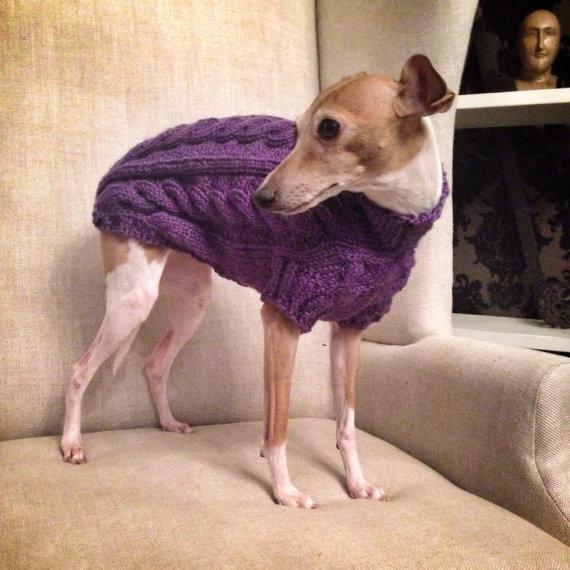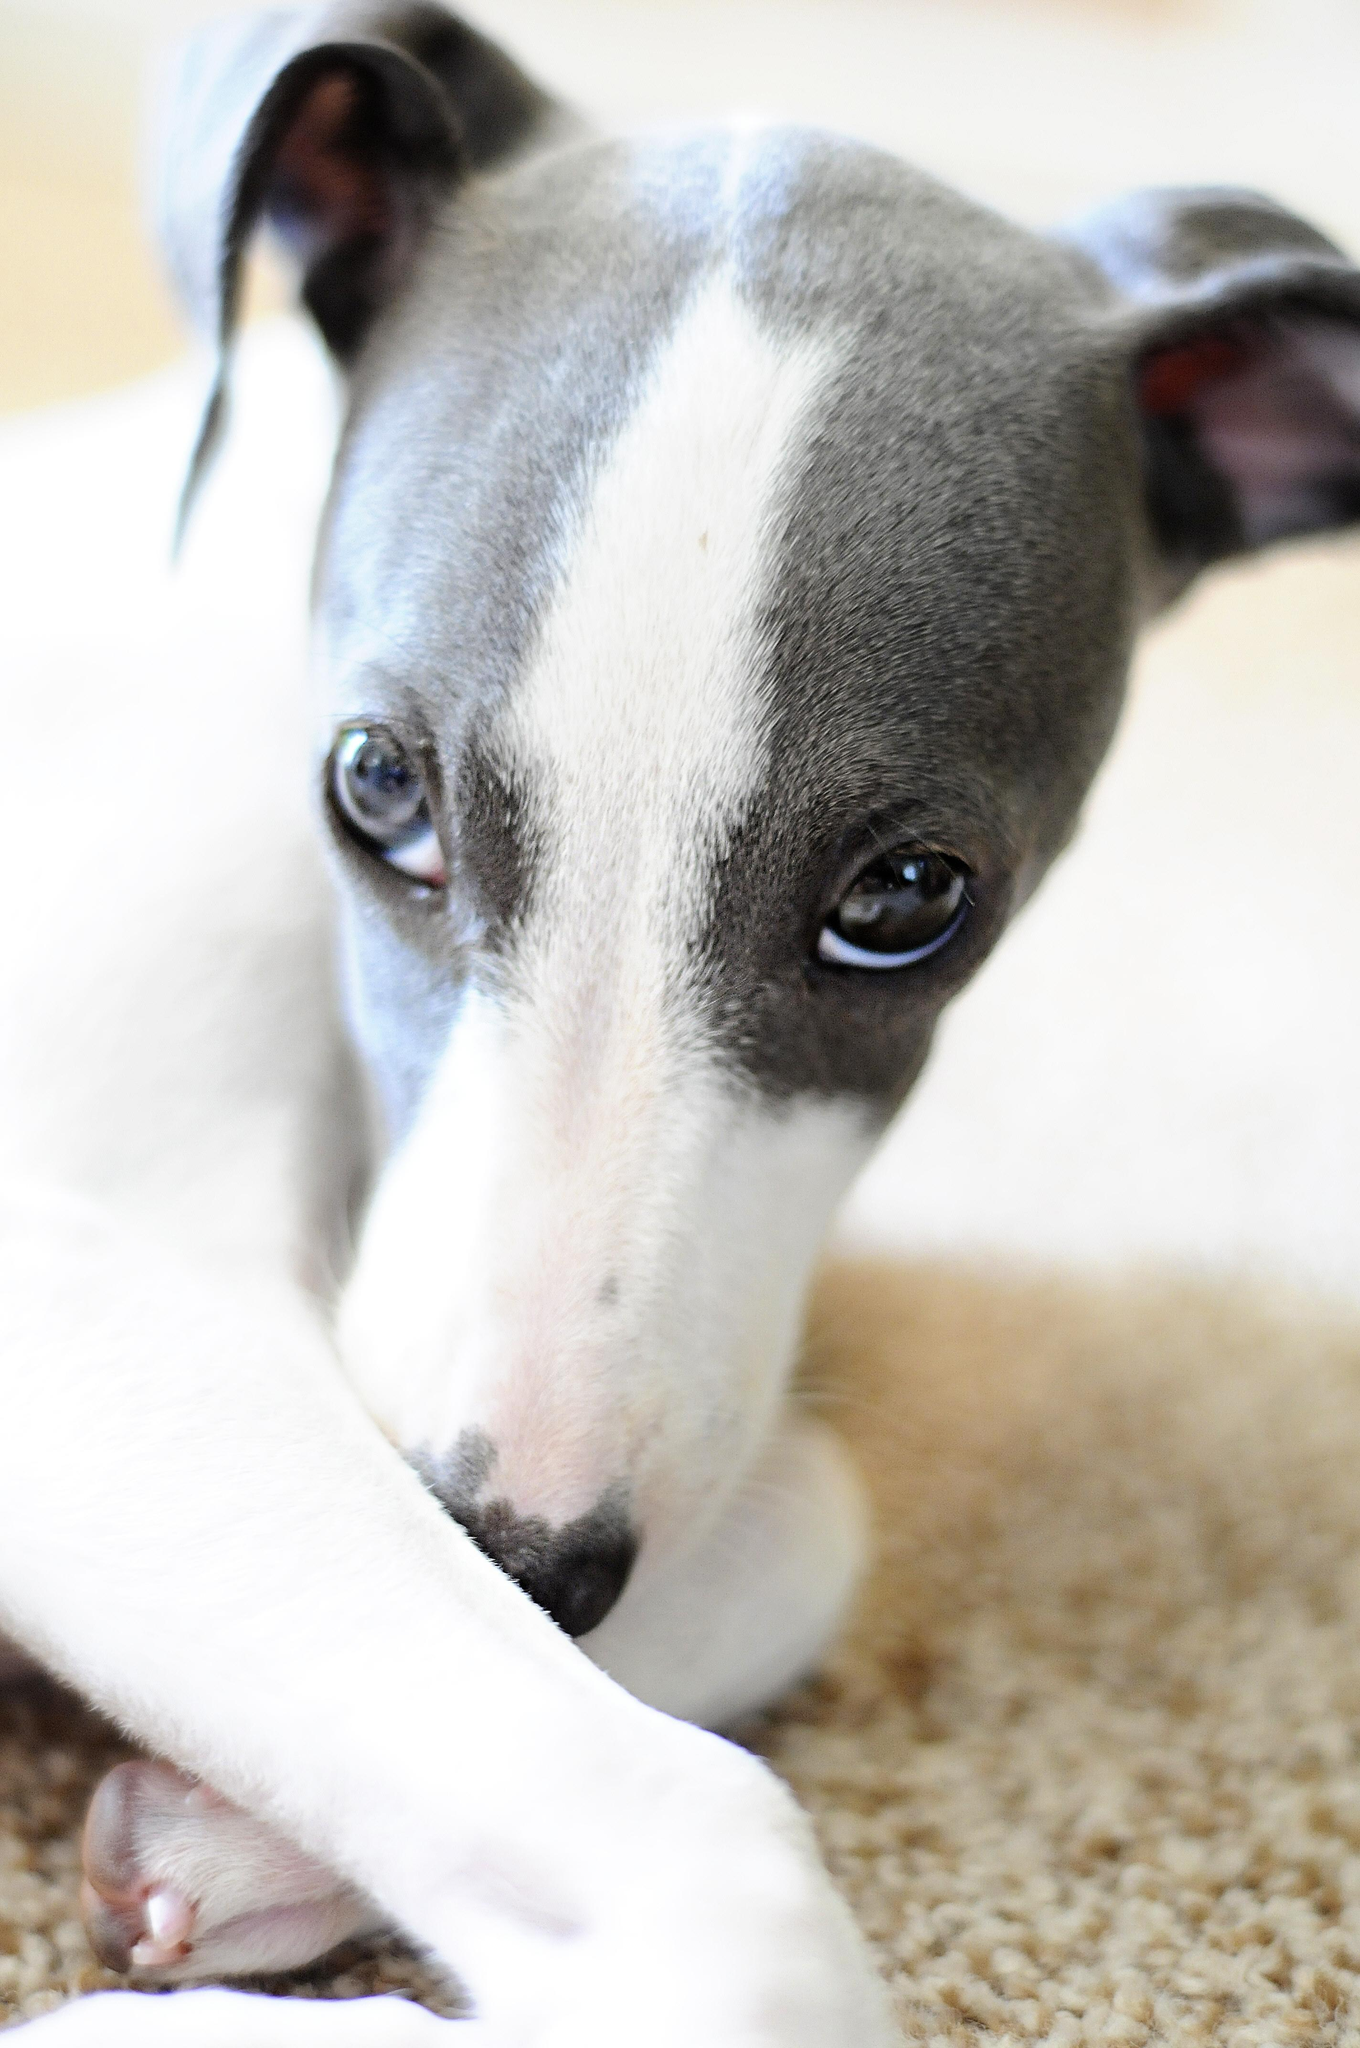The first image is the image on the left, the second image is the image on the right. Analyze the images presented: Is the assertion "At least one dog is sitting." valid? Answer yes or no. No. The first image is the image on the left, the second image is the image on the right. Considering the images on both sides, is "In the left image, there's an Italian Greyhound wearing a sweater and sitting." valid? Answer yes or no. No. 